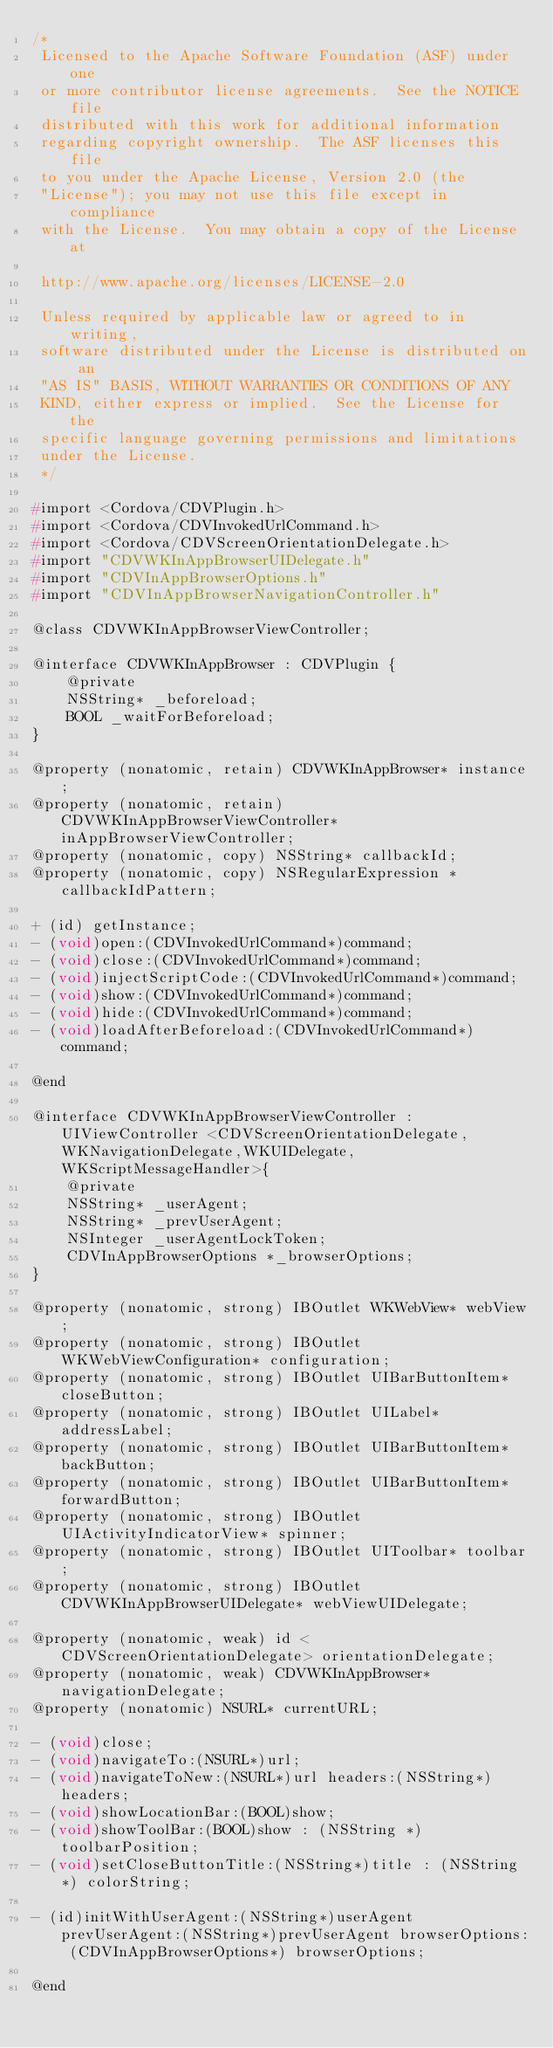Convert code to text. <code><loc_0><loc_0><loc_500><loc_500><_C_>/*
 Licensed to the Apache Software Foundation (ASF) under one
 or more contributor license agreements.  See the NOTICE file
 distributed with this work for additional information
 regarding copyright ownership.  The ASF licenses this file
 to you under the Apache License, Version 2.0 (the
 "License"); you may not use this file except in compliance
 with the License.  You may obtain a copy of the License at

 http://www.apache.org/licenses/LICENSE-2.0

 Unless required by applicable law or agreed to in writing,
 software distributed under the License is distributed on an
 "AS IS" BASIS, WITHOUT WARRANTIES OR CONDITIONS OF ANY
 KIND, either express or implied.  See the License for the
 specific language governing permissions and limitations
 under the License.
 */

#import <Cordova/CDVPlugin.h>
#import <Cordova/CDVInvokedUrlCommand.h>
#import <Cordova/CDVScreenOrientationDelegate.h>
#import "CDVWKInAppBrowserUIDelegate.h"
#import "CDVInAppBrowserOptions.h"
#import "CDVInAppBrowserNavigationController.h"

@class CDVWKInAppBrowserViewController;

@interface CDVWKInAppBrowser : CDVPlugin {
    @private
    NSString* _beforeload;
    BOOL _waitForBeforeload;
}

@property (nonatomic, retain) CDVWKInAppBrowser* instance;
@property (nonatomic, retain) CDVWKInAppBrowserViewController* inAppBrowserViewController;
@property (nonatomic, copy) NSString* callbackId;
@property (nonatomic, copy) NSRegularExpression *callbackIdPattern;

+ (id) getInstance;
- (void)open:(CDVInvokedUrlCommand*)command;
- (void)close:(CDVInvokedUrlCommand*)command;
- (void)injectScriptCode:(CDVInvokedUrlCommand*)command;
- (void)show:(CDVInvokedUrlCommand*)command;
- (void)hide:(CDVInvokedUrlCommand*)command;
- (void)loadAfterBeforeload:(CDVInvokedUrlCommand*)command;

@end

@interface CDVWKInAppBrowserViewController : UIViewController <CDVScreenOrientationDelegate,WKNavigationDelegate,WKUIDelegate,WKScriptMessageHandler>{
    @private
    NSString* _userAgent;
    NSString* _prevUserAgent;
    NSInteger _userAgentLockToken;
    CDVInAppBrowserOptions *_browserOptions;
}

@property (nonatomic, strong) IBOutlet WKWebView* webView;
@property (nonatomic, strong) IBOutlet WKWebViewConfiguration* configuration;
@property (nonatomic, strong) IBOutlet UIBarButtonItem* closeButton;
@property (nonatomic, strong) IBOutlet UILabel* addressLabel;
@property (nonatomic, strong) IBOutlet UIBarButtonItem* backButton;
@property (nonatomic, strong) IBOutlet UIBarButtonItem* forwardButton;
@property (nonatomic, strong) IBOutlet UIActivityIndicatorView* spinner;
@property (nonatomic, strong) IBOutlet UIToolbar* toolbar;
@property (nonatomic, strong) IBOutlet CDVWKInAppBrowserUIDelegate* webViewUIDelegate;

@property (nonatomic, weak) id <CDVScreenOrientationDelegate> orientationDelegate;
@property (nonatomic, weak) CDVWKInAppBrowser* navigationDelegate;
@property (nonatomic) NSURL* currentURL;

- (void)close;
- (void)navigateTo:(NSURL*)url;
- (void)navigateToNew:(NSURL*)url headers:(NSString*)headers;
- (void)showLocationBar:(BOOL)show;
- (void)showToolBar:(BOOL)show : (NSString *) toolbarPosition;
- (void)setCloseButtonTitle:(NSString*)title : (NSString*) colorString;

- (id)initWithUserAgent:(NSString*)userAgent prevUserAgent:(NSString*)prevUserAgent browserOptions: (CDVInAppBrowserOptions*) browserOptions;

@end
</code> 